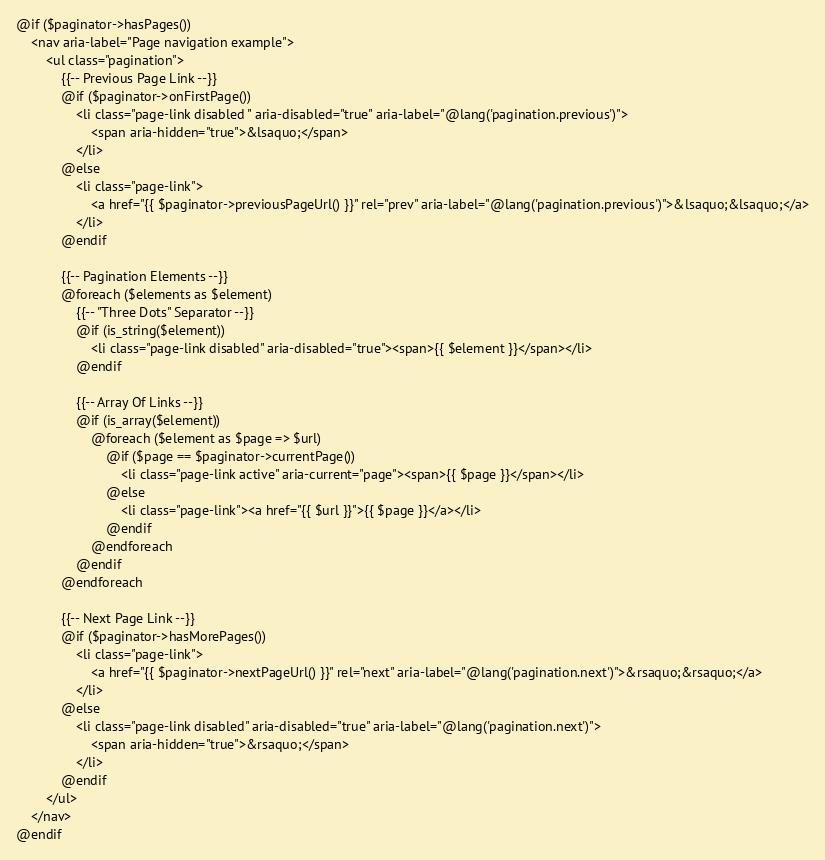Convert code to text. <code><loc_0><loc_0><loc_500><loc_500><_PHP_>@if ($paginator->hasPages())
    <nav aria-label="Page navigation example">
        <ul class="pagination">
            {{-- Previous Page Link --}}
            @if ($paginator->onFirstPage())
                <li class="page-link disabled " aria-disabled="true" aria-label="@lang('pagination.previous')">
                    <span aria-hidden="true">&lsaquo;</span>
                </li>
            @else
                <li class="page-link">
                    <a href="{{ $paginator->previousPageUrl() }}" rel="prev" aria-label="@lang('pagination.previous')">&lsaquo;&lsaquo;</a>
                </li>
            @endif

            {{-- Pagination Elements --}}
            @foreach ($elements as $element)
                {{-- "Three Dots" Separator --}}
                @if (is_string($element))
                    <li class="page-link disabled" aria-disabled="true"><span>{{ $element }}</span></li>
                @endif

                {{-- Array Of Links --}}
                @if (is_array($element))
                    @foreach ($element as $page => $url)
                        @if ($page == $paginator->currentPage())
                            <li class="page-link active" aria-current="page"><span>{{ $page }}</span></li>
                        @else
                            <li class="page-link"><a href="{{ $url }}">{{ $page }}</a></li>
                        @endif
                    @endforeach
                @endif
            @endforeach

            {{-- Next Page Link --}}
            @if ($paginator->hasMorePages())
                <li class="page-link">
                    <a href="{{ $paginator->nextPageUrl() }}" rel="next" aria-label="@lang('pagination.next')">&rsaquo;&rsaquo;</a>
                </li>
            @else
                <li class="page-link disabled" aria-disabled="true" aria-label="@lang('pagination.next')">
                    <span aria-hidden="true">&rsaquo;</span>
                </li>
            @endif
        </ul>
    </nav>
@endif
</code> 